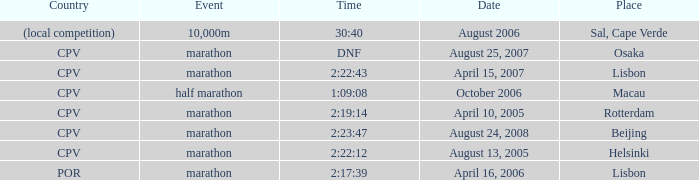What is the event titled country of (area competition)? 10,000m. 